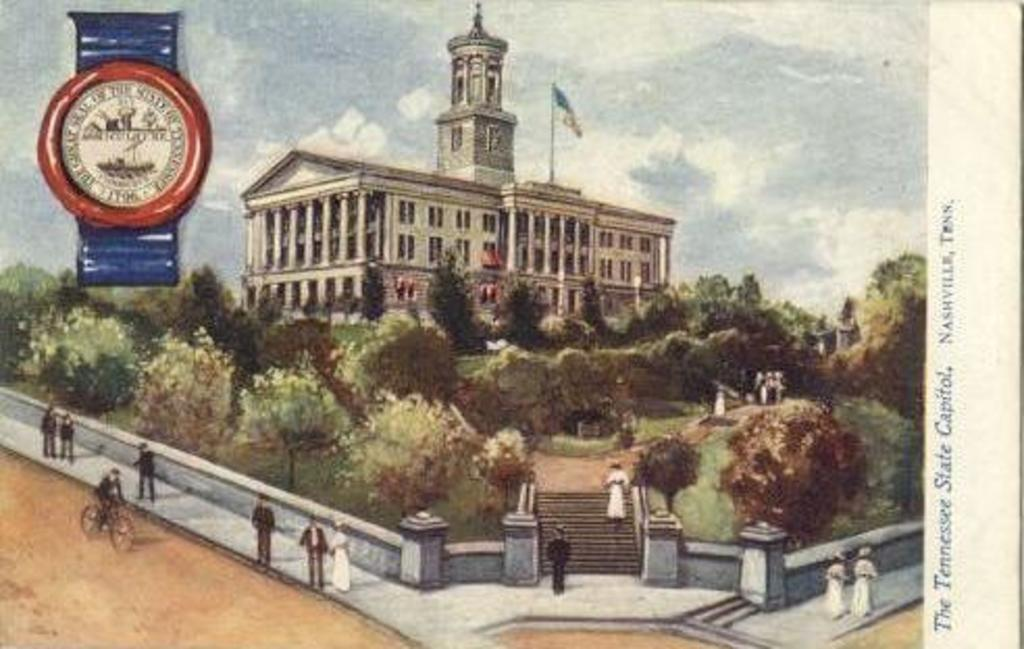<image>
Relay a brief, clear account of the picture shown. A building with a flag on it is shown and the word state is written to the side. 